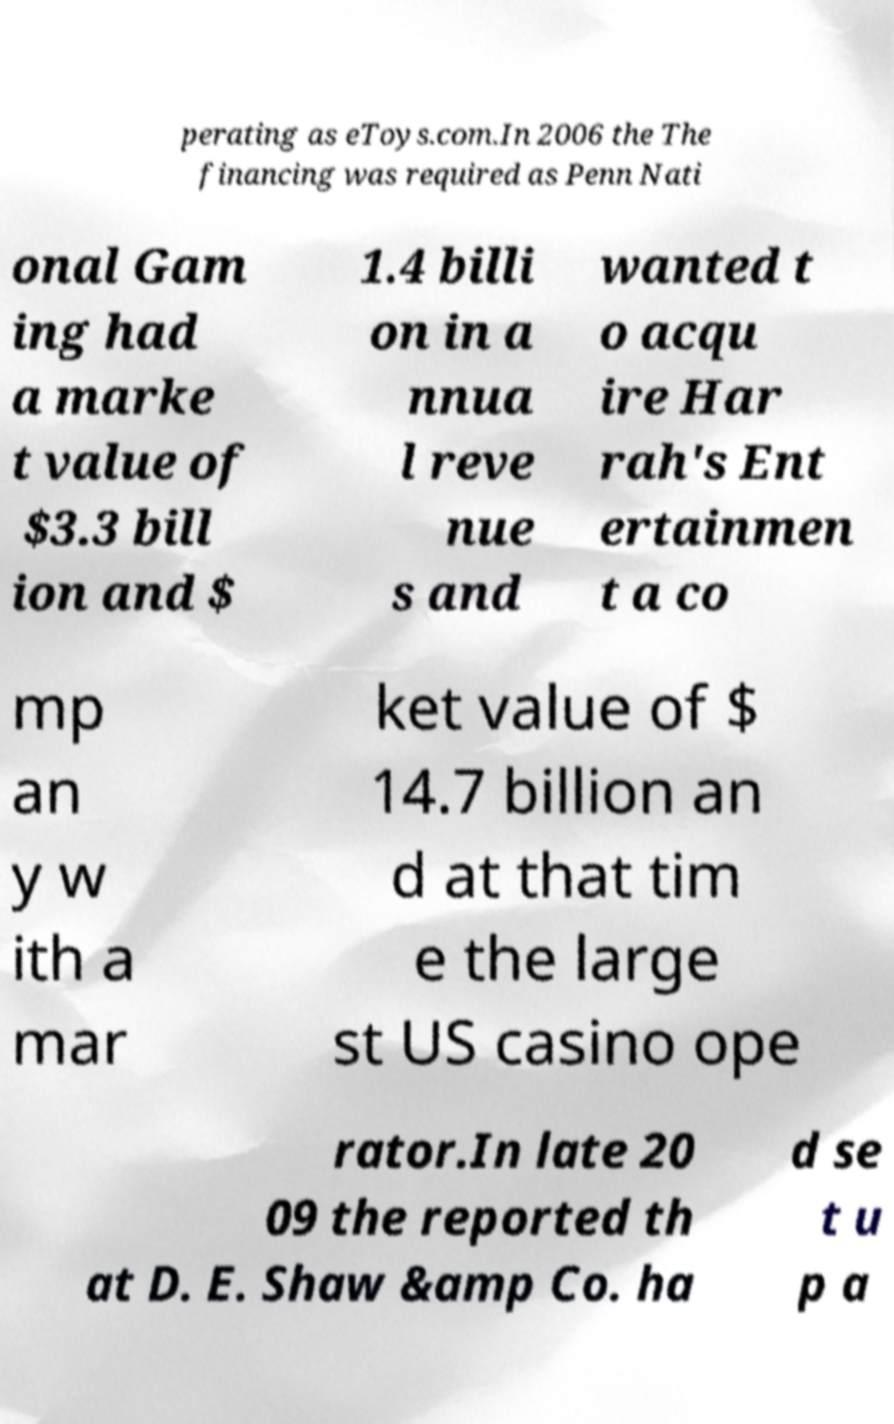Can you read and provide the text displayed in the image?This photo seems to have some interesting text. Can you extract and type it out for me? perating as eToys.com.In 2006 the The financing was required as Penn Nati onal Gam ing had a marke t value of $3.3 bill ion and $ 1.4 billi on in a nnua l reve nue s and wanted t o acqu ire Har rah's Ent ertainmen t a co mp an y w ith a mar ket value of $ 14.7 billion an d at that tim e the large st US casino ope rator.In late 20 09 the reported th at D. E. Shaw &amp Co. ha d se t u p a 